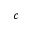Convert formula to latex. <formula><loc_0><loc_0><loc_500><loc_500>c</formula> 